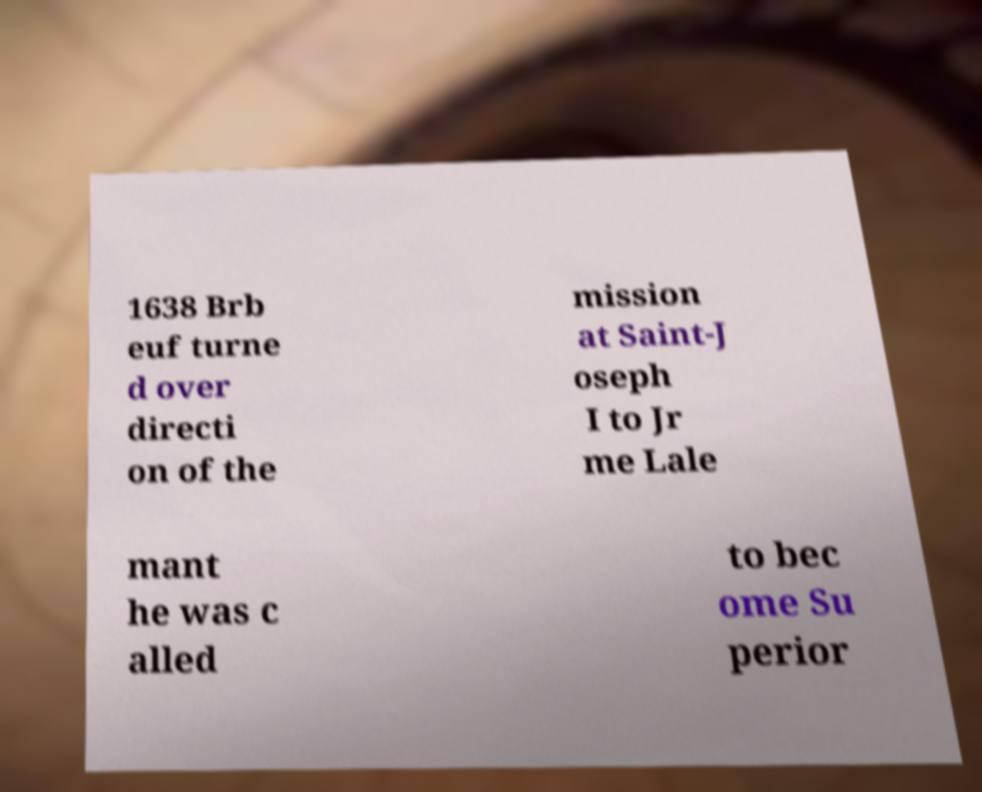What messages or text are displayed in this image? I need them in a readable, typed format. 1638 Brb euf turne d over directi on of the mission at Saint-J oseph I to Jr me Lale mant he was c alled to bec ome Su perior 